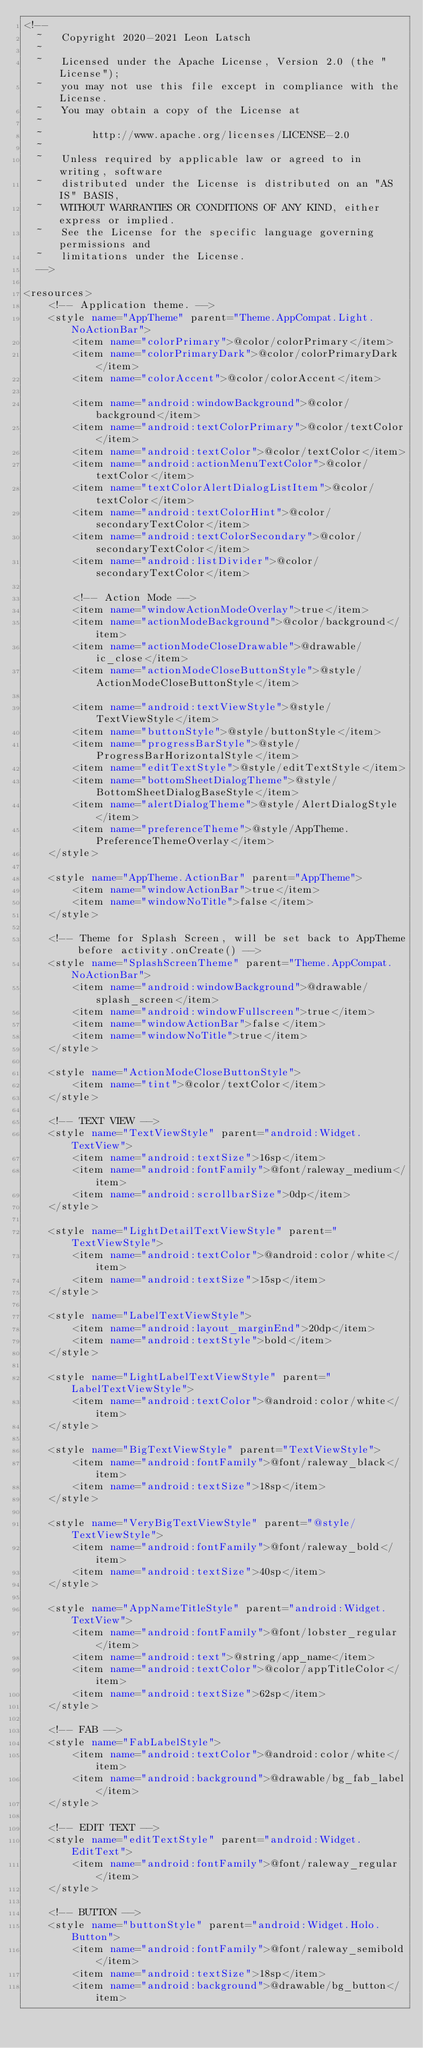<code> <loc_0><loc_0><loc_500><loc_500><_XML_><!--
  ~   Copyright 2020-2021 Leon Latsch
  ~
  ~   Licensed under the Apache License, Version 2.0 (the "License");
  ~   you may not use this file except in compliance with the License.
  ~   You may obtain a copy of the License at
  ~
  ~        http://www.apache.org/licenses/LICENSE-2.0
  ~
  ~   Unless required by applicable law or agreed to in writing, software
  ~   distributed under the License is distributed on an "AS IS" BASIS,
  ~   WITHOUT WARRANTIES OR CONDITIONS OF ANY KIND, either express or implied.
  ~   See the License for the specific language governing permissions and
  ~   limitations under the License.
  -->

<resources>
    <!-- Application theme. -->
    <style name="AppTheme" parent="Theme.AppCompat.Light.NoActionBar">
        <item name="colorPrimary">@color/colorPrimary</item>
        <item name="colorPrimaryDark">@color/colorPrimaryDark</item>
        <item name="colorAccent">@color/colorAccent</item>

        <item name="android:windowBackground">@color/background</item>
        <item name="android:textColorPrimary">@color/textColor</item>
        <item name="android:textColor">@color/textColor</item>
        <item name="android:actionMenuTextColor">@color/textColor</item>
        <item name="textColorAlertDialogListItem">@color/textColor</item>
        <item name="android:textColorHint">@color/secondaryTextColor</item>
        <item name="android:textColorSecondary">@color/secondaryTextColor</item>
        <item name="android:listDivider">@color/secondaryTextColor</item>

        <!-- Action Mode -->
        <item name="windowActionModeOverlay">true</item>
        <item name="actionModeBackground">@color/background</item>
        <item name="actionModeCloseDrawable">@drawable/ic_close</item>
        <item name="actionModeCloseButtonStyle">@style/ActionModeCloseButtonStyle</item>

        <item name="android:textViewStyle">@style/TextViewStyle</item>
        <item name="buttonStyle">@style/buttonStyle</item>
        <item name="progressBarStyle">@style/ProgressBarHorizontalStyle</item>
        <item name="editTextStyle">@style/editTextStyle</item>
        <item name="bottomSheetDialogTheme">@style/BottomSheetDialogBaseStyle</item>
        <item name="alertDialogTheme">@style/AlertDialogStyle</item>
        <item name="preferenceTheme">@style/AppTheme.PreferenceThemeOverlay</item>
    </style>

    <style name="AppTheme.ActionBar" parent="AppTheme">
        <item name="windowActionBar">true</item>
        <item name="windowNoTitle">false</item>
    </style>

    <!-- Theme for Splash Screen, will be set back to AppTheme before activity.onCreate() -->
    <style name="SplashScreenTheme" parent="Theme.AppCompat.NoActionBar">
        <item name="android:windowBackground">@drawable/splash_screen</item>
        <item name="android:windowFullscreen">true</item>
        <item name="windowActionBar">false</item>
        <item name="windowNoTitle">true</item>
    </style>

    <style name="ActionModeCloseButtonStyle">
        <item name="tint">@color/textColor</item>
    </style>

    <!-- TEXT VIEW -->
    <style name="TextViewStyle" parent="android:Widget.TextView">
        <item name="android:textSize">16sp</item>
        <item name="android:fontFamily">@font/raleway_medium</item>
        <item name="android:scrollbarSize">0dp</item>
    </style>

    <style name="LightDetailTextViewStyle" parent="TextViewStyle">
        <item name="android:textColor">@android:color/white</item>
        <item name="android:textSize">15sp</item>
    </style>

    <style name="LabelTextViewStyle">
        <item name="android:layout_marginEnd">20dp</item>
        <item name="android:textStyle">bold</item>
    </style>

    <style name="LightLabelTextViewStyle" parent="LabelTextViewStyle">
        <item name="android:textColor">@android:color/white</item>
    </style>

    <style name="BigTextViewStyle" parent="TextViewStyle">
        <item name="android:fontFamily">@font/raleway_black</item>
        <item name="android:textSize">18sp</item>
    </style>

    <style name="VeryBigTextViewStyle" parent="@style/TextViewStyle">
        <item name="android:fontFamily">@font/raleway_bold</item>
        <item name="android:textSize">40sp</item>
    </style>

    <style name="AppNameTitleStyle" parent="android:Widget.TextView">
        <item name="android:fontFamily">@font/lobster_regular</item>
        <item name="android:text">@string/app_name</item>
        <item name="android:textColor">@color/appTitleColor</item>
        <item name="android:textSize">62sp</item>
    </style>

    <!-- FAB -->
    <style name="FabLabelStyle">
        <item name="android:textColor">@android:color/white</item>
        <item name="android:background">@drawable/bg_fab_label</item>
    </style>

    <!-- EDIT TEXT -->
    <style name="editTextStyle" parent="android:Widget.EditText">
        <item name="android:fontFamily">@font/raleway_regular</item>
    </style>

    <!-- BUTTON -->
    <style name="buttonStyle" parent="android:Widget.Holo.Button">
        <item name="android:fontFamily">@font/raleway_semibold</item>
        <item name="android:textSize">18sp</item>
        <item name="android:background">@drawable/bg_button</item></code> 